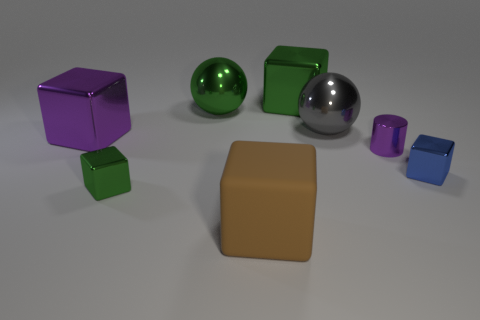Which objects are closest to the large tan rubber block in the image? The closest objects to the large tan rubber block are the small purple metal cube to its upper right and the blue metal cube to its lower right. All other objects are a bit farther away from the large rubber block. 